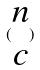Convert formula to latex. <formula><loc_0><loc_0><loc_500><loc_500>( \begin{matrix} n \\ c \end{matrix} )</formula> 